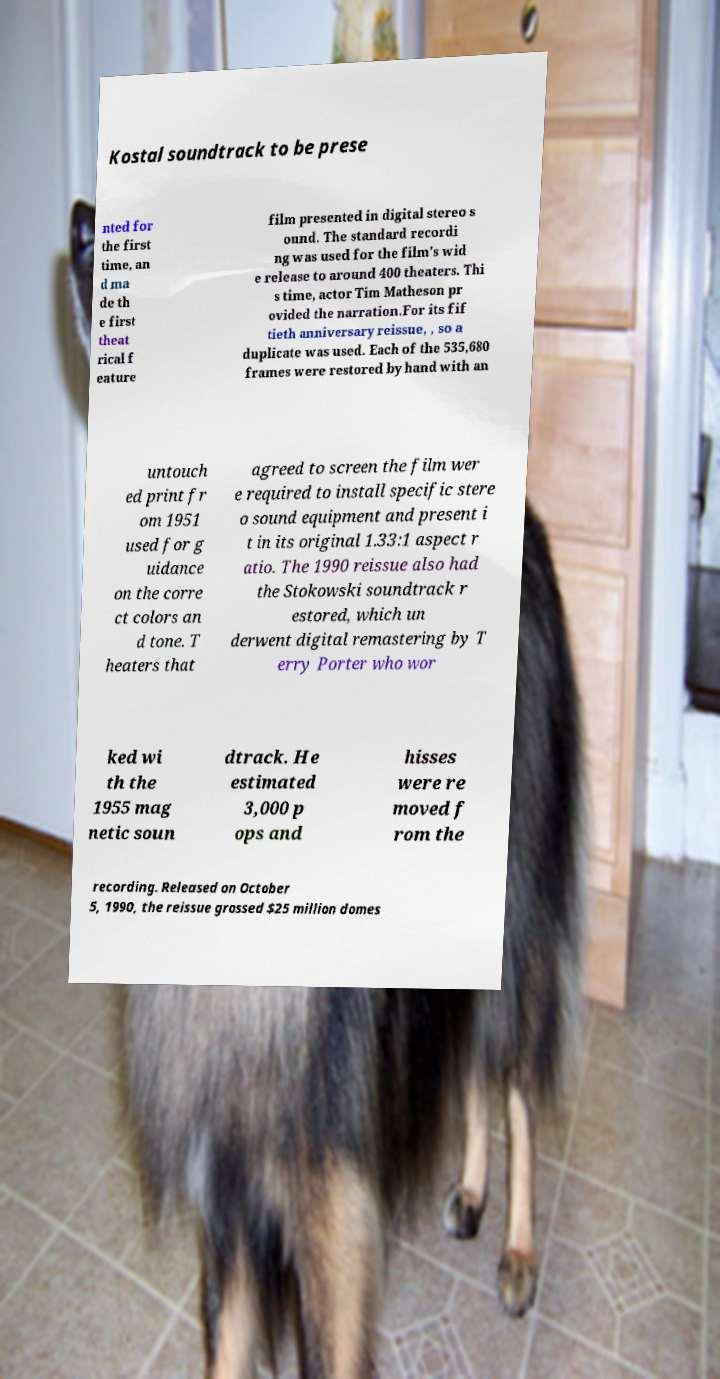I need the written content from this picture converted into text. Can you do that? Kostal soundtrack to be prese nted for the first time, an d ma de th e first theat rical f eature film presented in digital stereo s ound. The standard recordi ng was used for the film's wid e release to around 400 theaters. Thi s time, actor Tim Matheson pr ovided the narration.For its fif tieth anniversary reissue, , so a duplicate was used. Each of the 535,680 frames were restored by hand with an untouch ed print fr om 1951 used for g uidance on the corre ct colors an d tone. T heaters that agreed to screen the film wer e required to install specific stere o sound equipment and present i t in its original 1.33:1 aspect r atio. The 1990 reissue also had the Stokowski soundtrack r estored, which un derwent digital remastering by T erry Porter who wor ked wi th the 1955 mag netic soun dtrack. He estimated 3,000 p ops and hisses were re moved f rom the recording. Released on October 5, 1990, the reissue grossed $25 million domes 